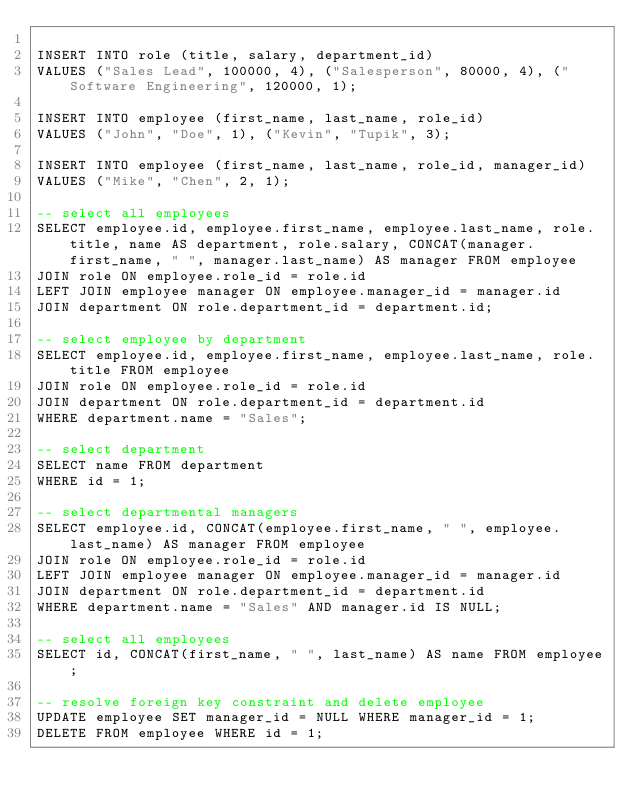<code> <loc_0><loc_0><loc_500><loc_500><_SQL_>
INSERT INTO role (title, salary, department_id)
VALUES ("Sales Lead", 100000, 4), ("Salesperson", 80000, 4), ("Software Engineering", 120000, 1);

INSERT INTO employee (first_name, last_name, role_id)
VALUES ("John", "Doe", 1), ("Kevin", "Tupik", 3);

INSERT INTO employee (first_name, last_name, role_id, manager_id)
VALUES ("Mike", "Chen", 2, 1);

-- select all employees
SELECT employee.id, employee.first_name, employee.last_name, role.title, name AS department, role.salary, CONCAT(manager.first_name, " ", manager.last_name) AS manager FROM employee 
JOIN role ON employee.role_id = role.id
LEFT JOIN employee manager ON employee.manager_id = manager.id
JOIN department ON role.department_id = department.id;

-- select employee by department
SELECT employee.id, employee.first_name, employee.last_name, role.title FROM employee 
JOIN role ON employee.role_id = role.id
JOIN department ON role.department_id = department.id
WHERE department.name = "Sales";

-- select department
SELECT name FROM department 
WHERE id = 1;

-- select departmental managers
SELECT employee.id, CONCAT(employee.first_name, " ", employee.last_name) AS manager FROM employee 
JOIN role ON employee.role_id = role.id
LEFT JOIN employee manager ON employee.manager_id = manager.id
JOIN department ON role.department_id = department.id
WHERE department.name = "Sales" AND manager.id IS NULL;

-- select all employees
SELECT id, CONCAT(first_name, " ", last_name) AS name FROM employee;

-- resolve foreign key constraint and delete employee
UPDATE employee SET manager_id = NULL WHERE manager_id = 1;
DELETE FROM employee WHERE id = 1;</code> 